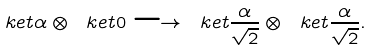Convert formula to latex. <formula><loc_0><loc_0><loc_500><loc_500>\ k e t { \alpha } \otimes \ k e t { 0 } \longrightarrow \ k e t { \frac { \alpha } { \sqrt { 2 } } } \otimes \ k e t { \frac { \alpha } { \sqrt { 2 } } } .</formula> 